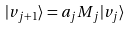<formula> <loc_0><loc_0><loc_500><loc_500>| v _ { j + 1 } \rangle = a _ { j } M _ { j } | v _ { j } \rangle</formula> 